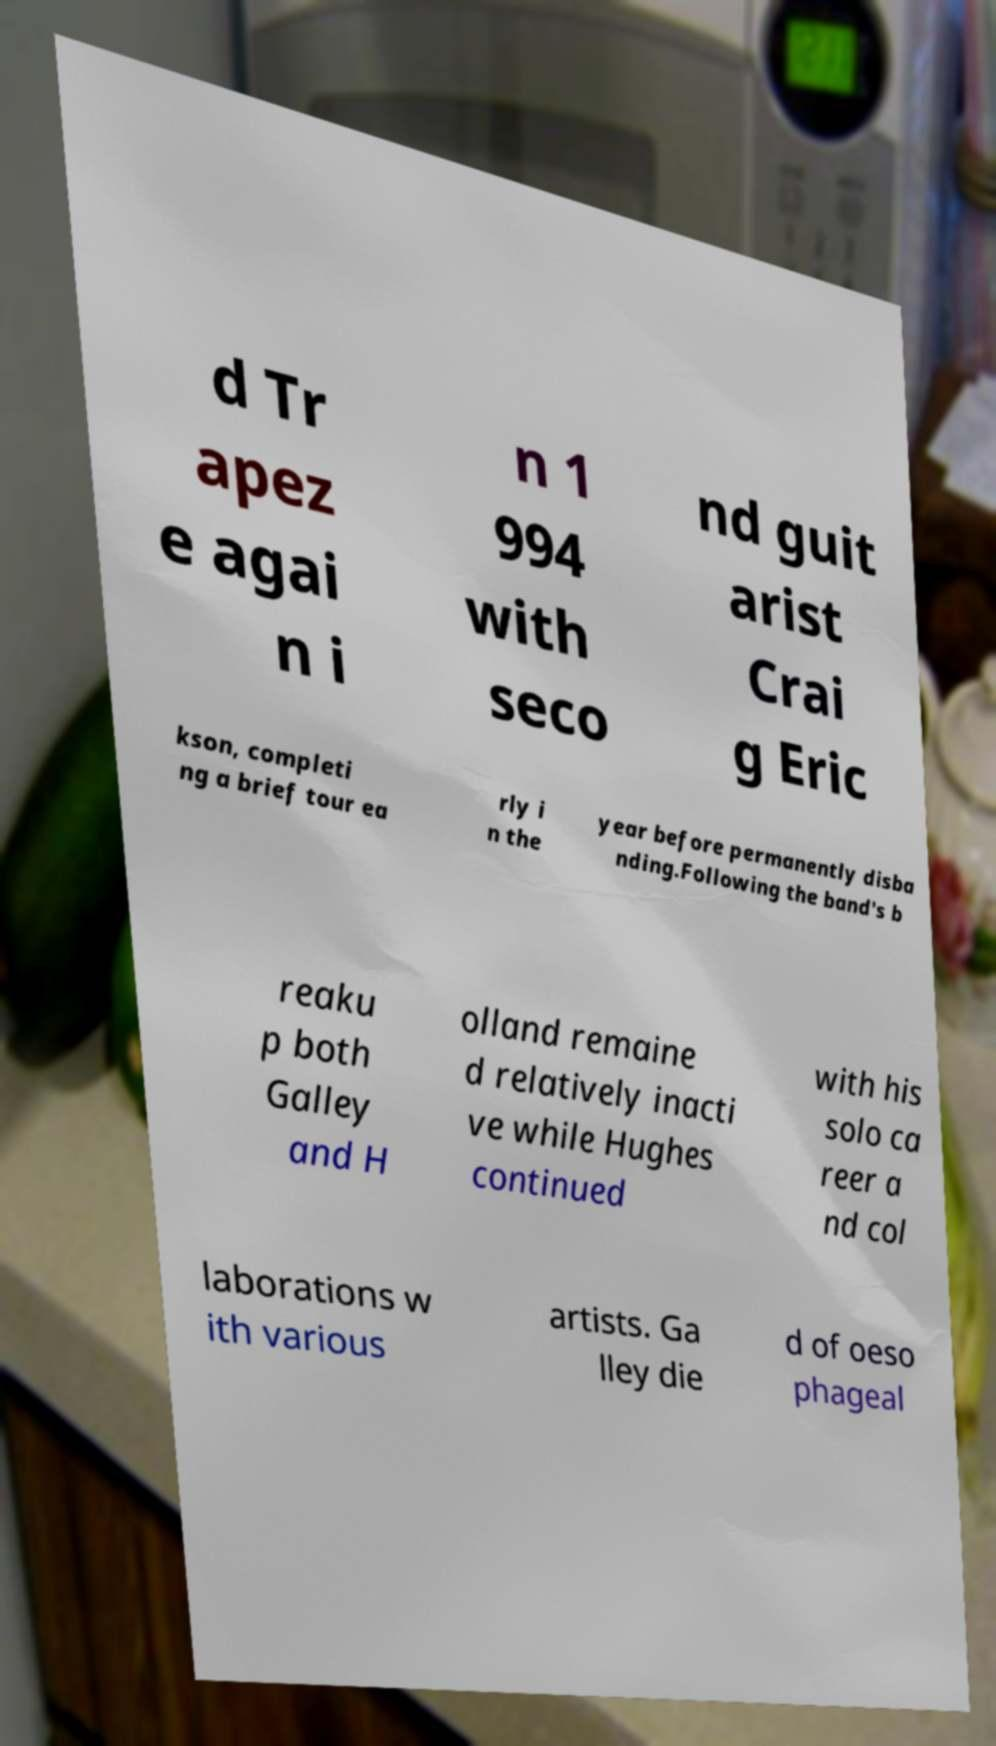There's text embedded in this image that I need extracted. Can you transcribe it verbatim? d Tr apez e agai n i n 1 994 with seco nd guit arist Crai g Eric kson, completi ng a brief tour ea rly i n the year before permanently disba nding.Following the band's b reaku p both Galley and H olland remaine d relatively inacti ve while Hughes continued with his solo ca reer a nd col laborations w ith various artists. Ga lley die d of oeso phageal 